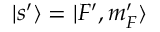Convert formula to latex. <formula><loc_0><loc_0><loc_500><loc_500>| s ^ { \prime } \rangle = | F ^ { \prime } , m _ { F } ^ { \prime } \rangle</formula> 